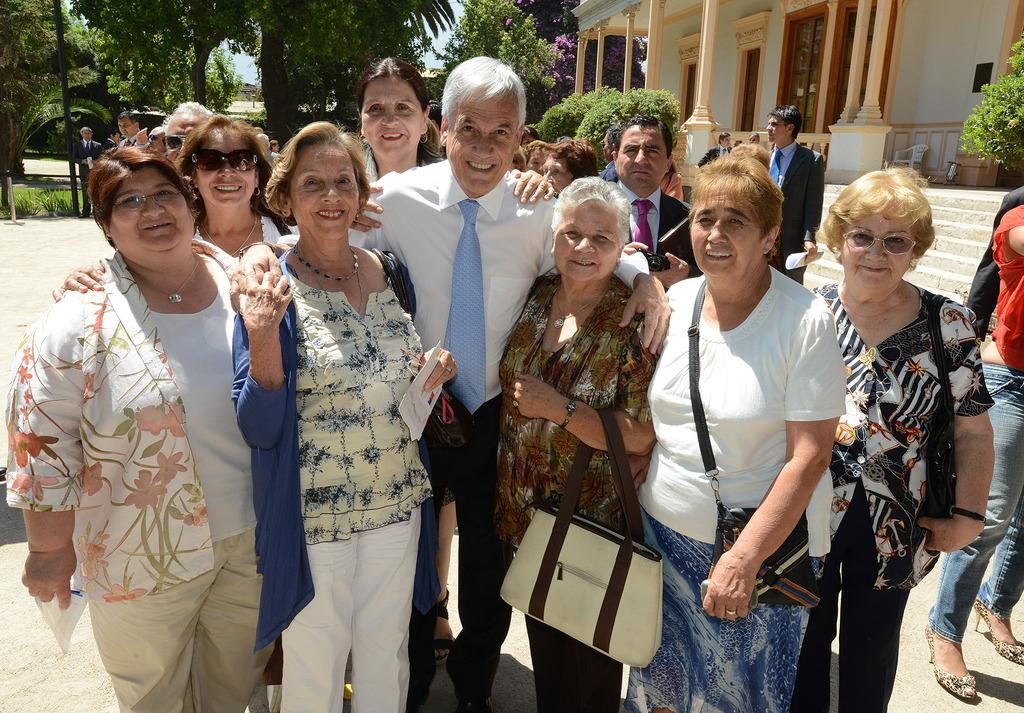What are the people in the image doing? The people in the image are standing. What are some of the people holding in the image? Some of the people are holding papers. What objects can be seen near the people in the image? Bags are visible in the image. What can be seen in the background of the image? There is a building, bushes, trees, and the sky. What type of cable is being used to connect the oven to the hate in the image? There is no cable, oven, or hate present in the image. 